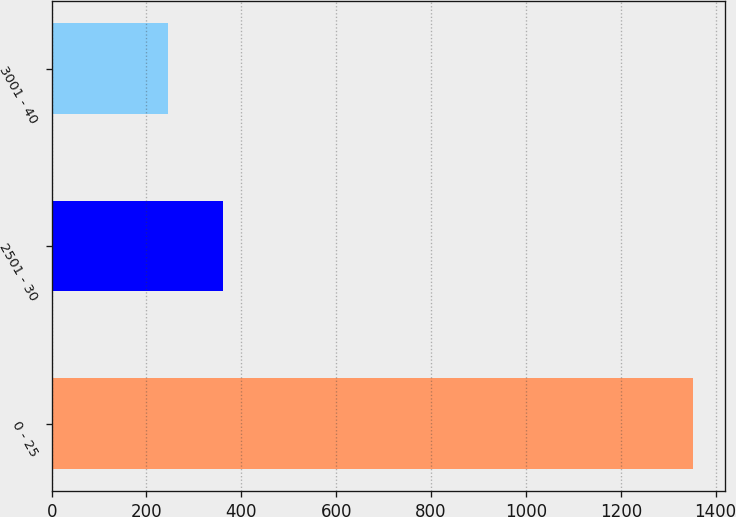Convert chart. <chart><loc_0><loc_0><loc_500><loc_500><bar_chart><fcel>0 - 25<fcel>2501 - 30<fcel>3001 - 40<nl><fcel>1352<fcel>362<fcel>245<nl></chart> 